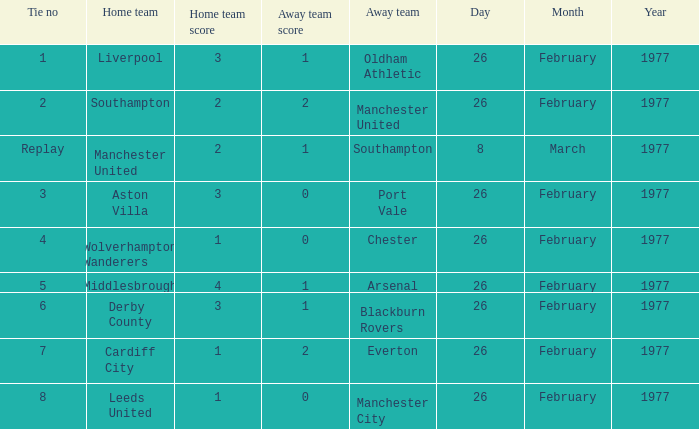What's the score when the tie number was 6? 3–1. 